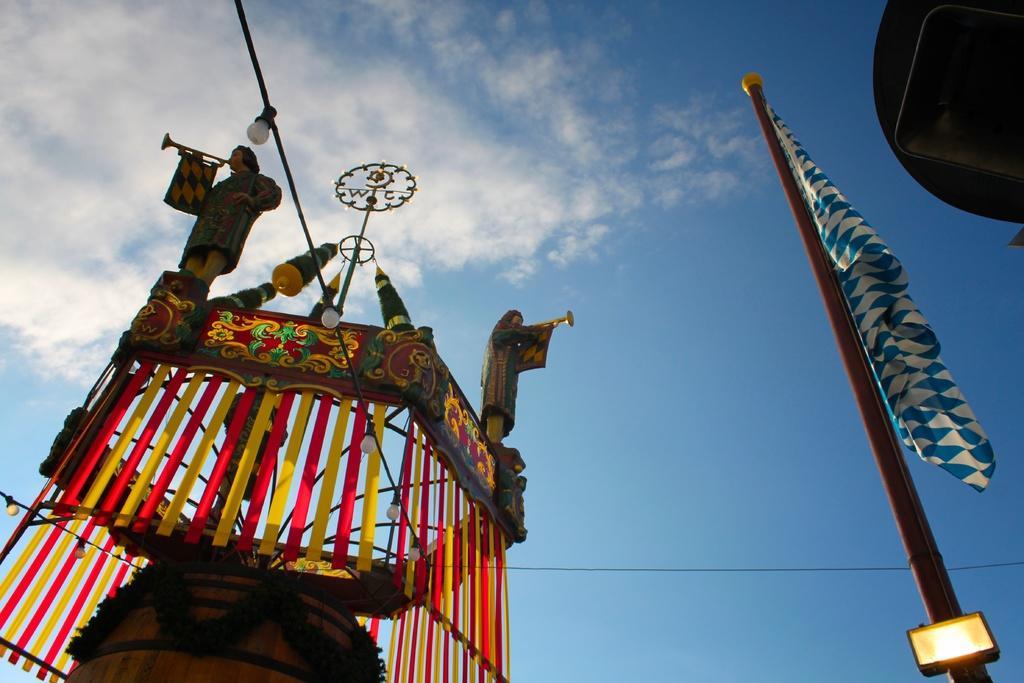Please provide a concise description of this image. In this picture there is an object on the left side, there is a flag on the right side. And the sky is at the top. 